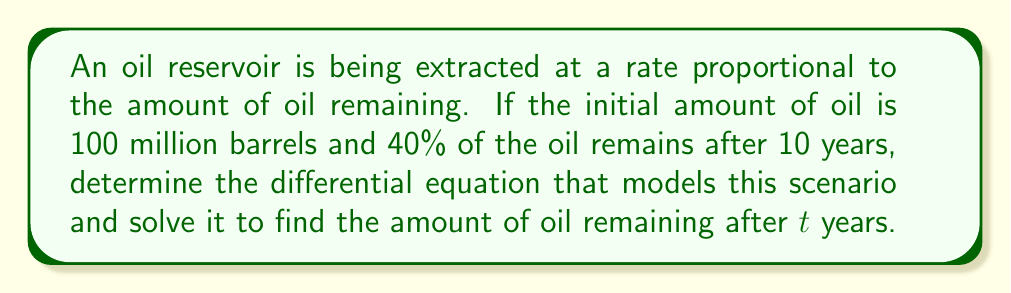Give your solution to this math problem. Step 1: Set up the differential equation
Let $Q(t)$ be the amount of oil remaining after t years.
The rate of change is proportional to the amount remaining:
$$\frac{dQ}{dt} = -kQ$$
where $k$ is the extraction rate constant.

Step 2: Use the initial condition
At $t=0$, $Q(0) = 100$ million barrels

Step 3: Solve the differential equation
The general solution is:
$$Q(t) = Ce^{-kt}$$
where $C$ is a constant.

Using the initial condition:
$$100 = Ce^{-k(0)}$$
$$C = 100$$

So, the specific solution is:
$$Q(t) = 100e^{-kt}$$

Step 4: Use the given information to find $k$
After 10 years, 40% remains:
$$40 = 100e^{-k(10)}$$
$$0.4 = e^{-10k}$$
$$\ln(0.4) = -10k$$
$$k = -\frac{\ln(0.4)}{10} \approx 0.0916$$

Step 5: Write the final equation
$$Q(t) = 100e^{-0.0916t}$$

This equation gives the amount of oil remaining (in million barrels) after $t$ years.
Answer: $Q(t) = 100e^{-0.0916t}$ million barrels 